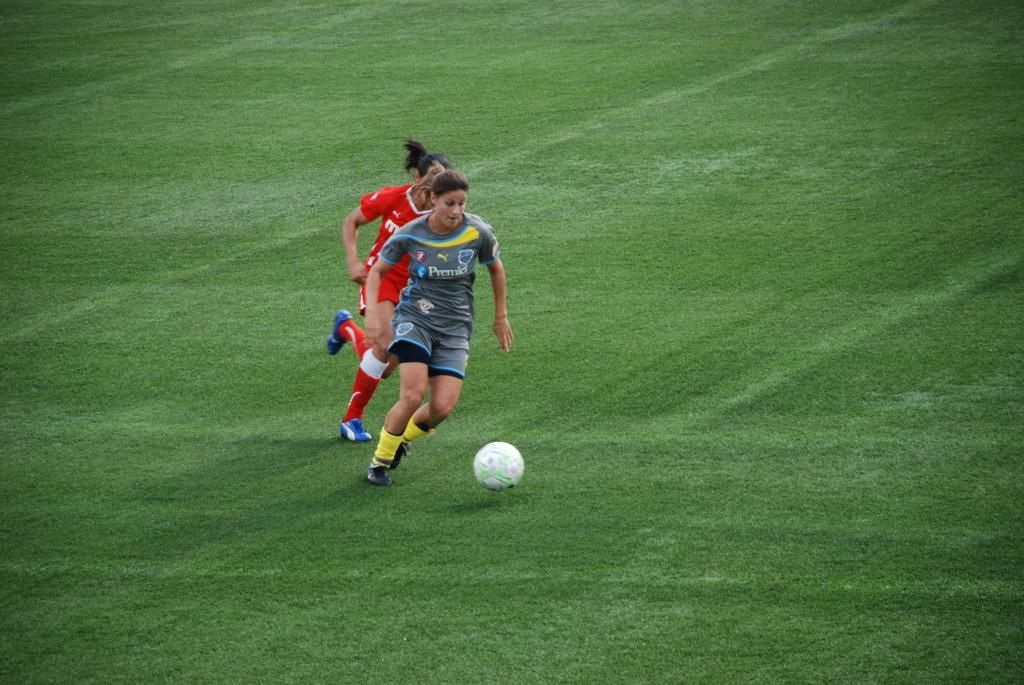Who is present in the image? There are women in the image. What object can be seen on the ground in the image? There is a ball on the ground in the image. How many pizzas are being served to the women in the image? There is no information about pizzas in the image, so we cannot determine if any are being served. 